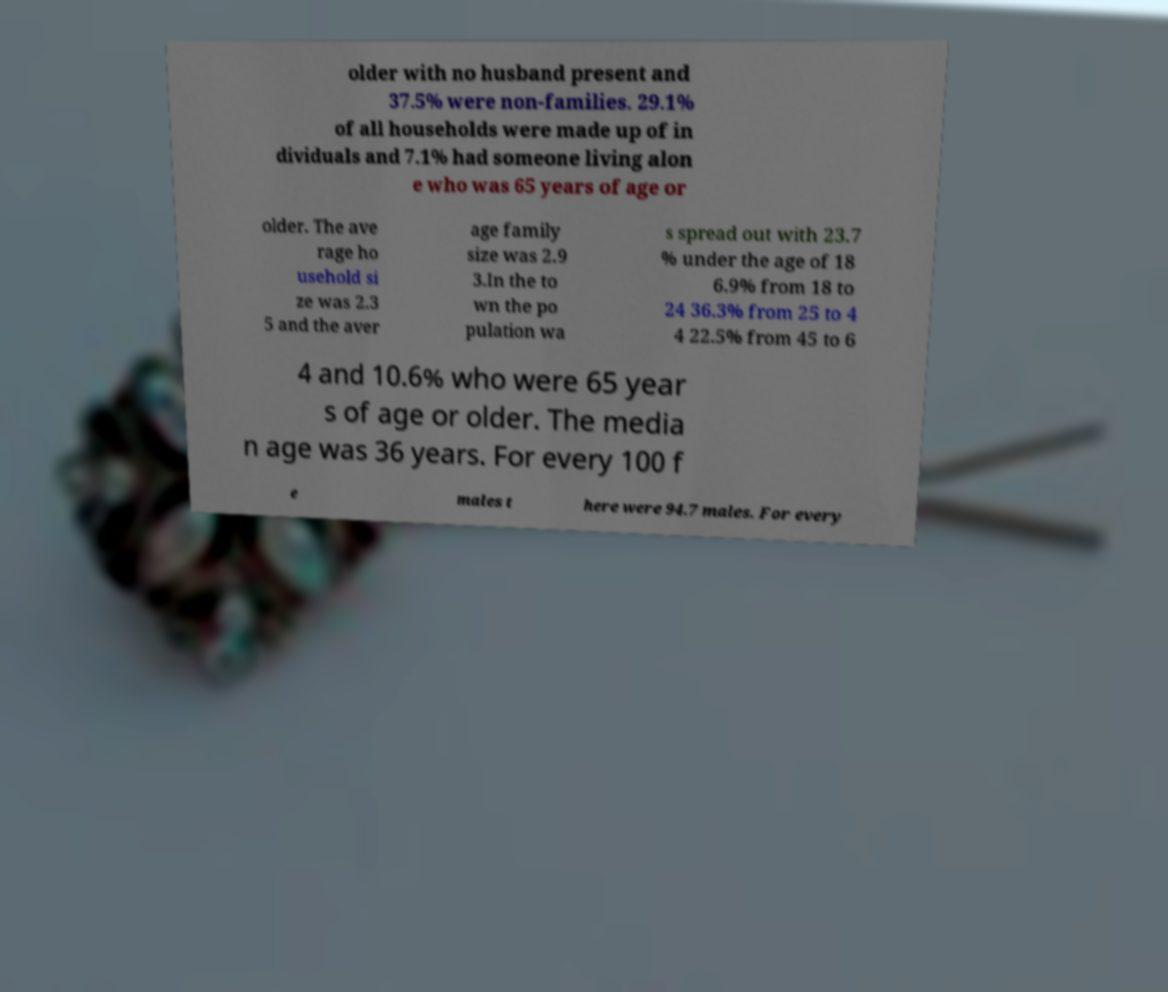Can you read and provide the text displayed in the image?This photo seems to have some interesting text. Can you extract and type it out for me? older with no husband present and 37.5% were non-families. 29.1% of all households were made up of in dividuals and 7.1% had someone living alon e who was 65 years of age or older. The ave rage ho usehold si ze was 2.3 5 and the aver age family size was 2.9 3.In the to wn the po pulation wa s spread out with 23.7 % under the age of 18 6.9% from 18 to 24 36.3% from 25 to 4 4 22.5% from 45 to 6 4 and 10.6% who were 65 year s of age or older. The media n age was 36 years. For every 100 f e males t here were 94.7 males. For every 